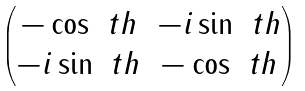Convert formula to latex. <formula><loc_0><loc_0><loc_500><loc_500>\begin{pmatrix} - \cos \ t h & - i \sin \ t h \\ - i \sin \ t h & - \cos \ t h \\ \end{pmatrix}</formula> 